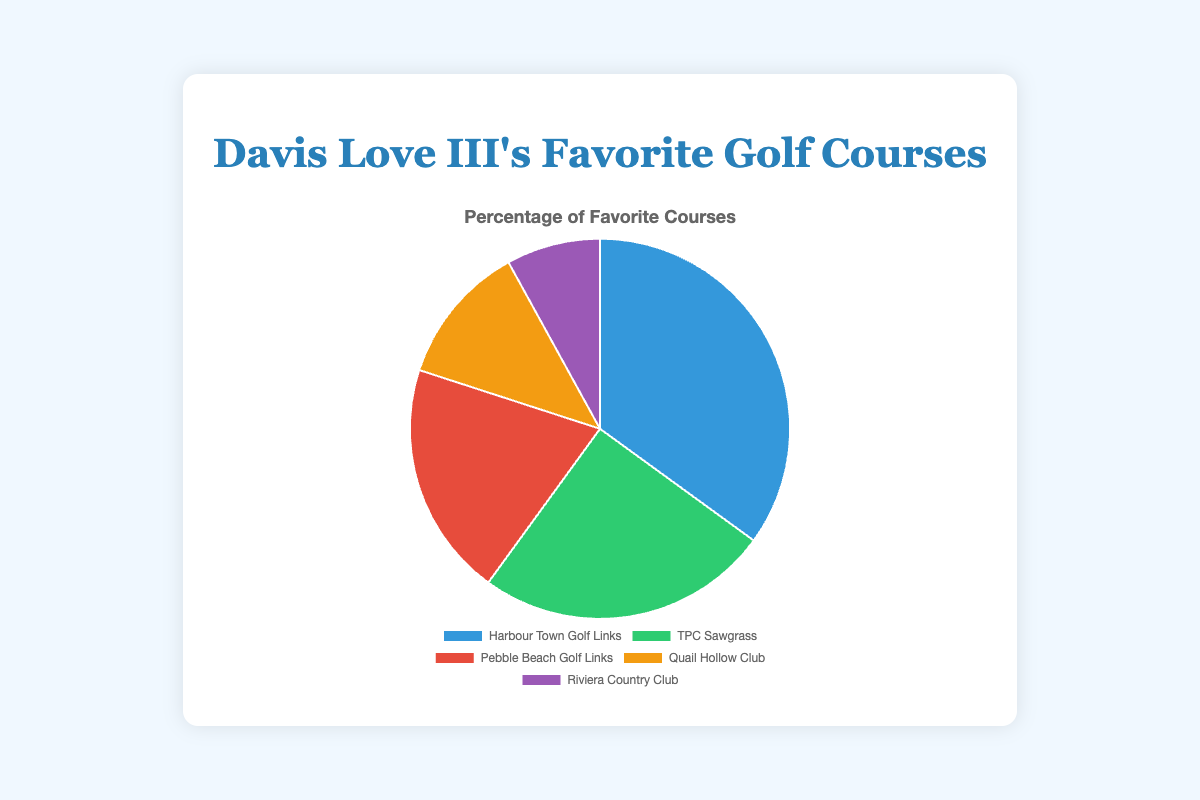What's the most popular golf course played by Davis Love III according to the pie chart? The largest segment in the pie chart represents the most popular course. Harbour Town Golf Links has the largest segment at 35%.
Answer: Harbour Town Golf Links What's the difference in percentage between the top two favorite courses? The top two courses are Harbour Town Golf Links (35%) and TPC Sawgrass (25%). The difference is 35% - 25% = 10%.
Answer: 10% Which golf course has the smallest percentage in the pie chart? The smallest segment in the pie chart represents the course with the smallest percentage. Riviera Country Club has the smallest segment at 8%.
Answer: Riviera Country Club How many courses have a percentage greater than 20%? By examining the pie chart, Harbour Town Golf Links (35%) and TPC Sawgrass (25%) have percentages greater than 20%.
Answer: 2 What is the total percentage of the least and most favorite golf courses combined? The least favorite course is Riviera Country Club (8%), and the most favorite is Harbour Town Golf Links (35%). The total is 8% + 35% = 43%.
Answer: 43% Which golf course is represented by the yellow segment in the pie chart? By visually identifying the colors, the yellow segment represents Quail Hollow Club with 12%.
Answer: Quail Hollow Club If percentages are doubled, what would be the new percentage for Pebble Beach Golf Links? The original percentage for Pebble Beach Golf Links is 20%. Doubling it would be 20% x 2 = 40%.
Answer: 40% What's the combined percentage of courses not played more than 20%? Courses not played more than 20% are Pebble Beach Golf Links (20%), Quail Hollow Club (12%), and Riviera Country Club (8%). Combined, they are 20% + 12% + 8% = 40%.
Answer: 40% Among TPC Sawgrass and Quail Hollow Club, which course has a larger percentage? By comparing the two segments, TPC Sawgrass has 25% while Quail Hollow Club has 12%. TPC Sawgrass has the larger percentage.
Answer: TPC Sawgrass 